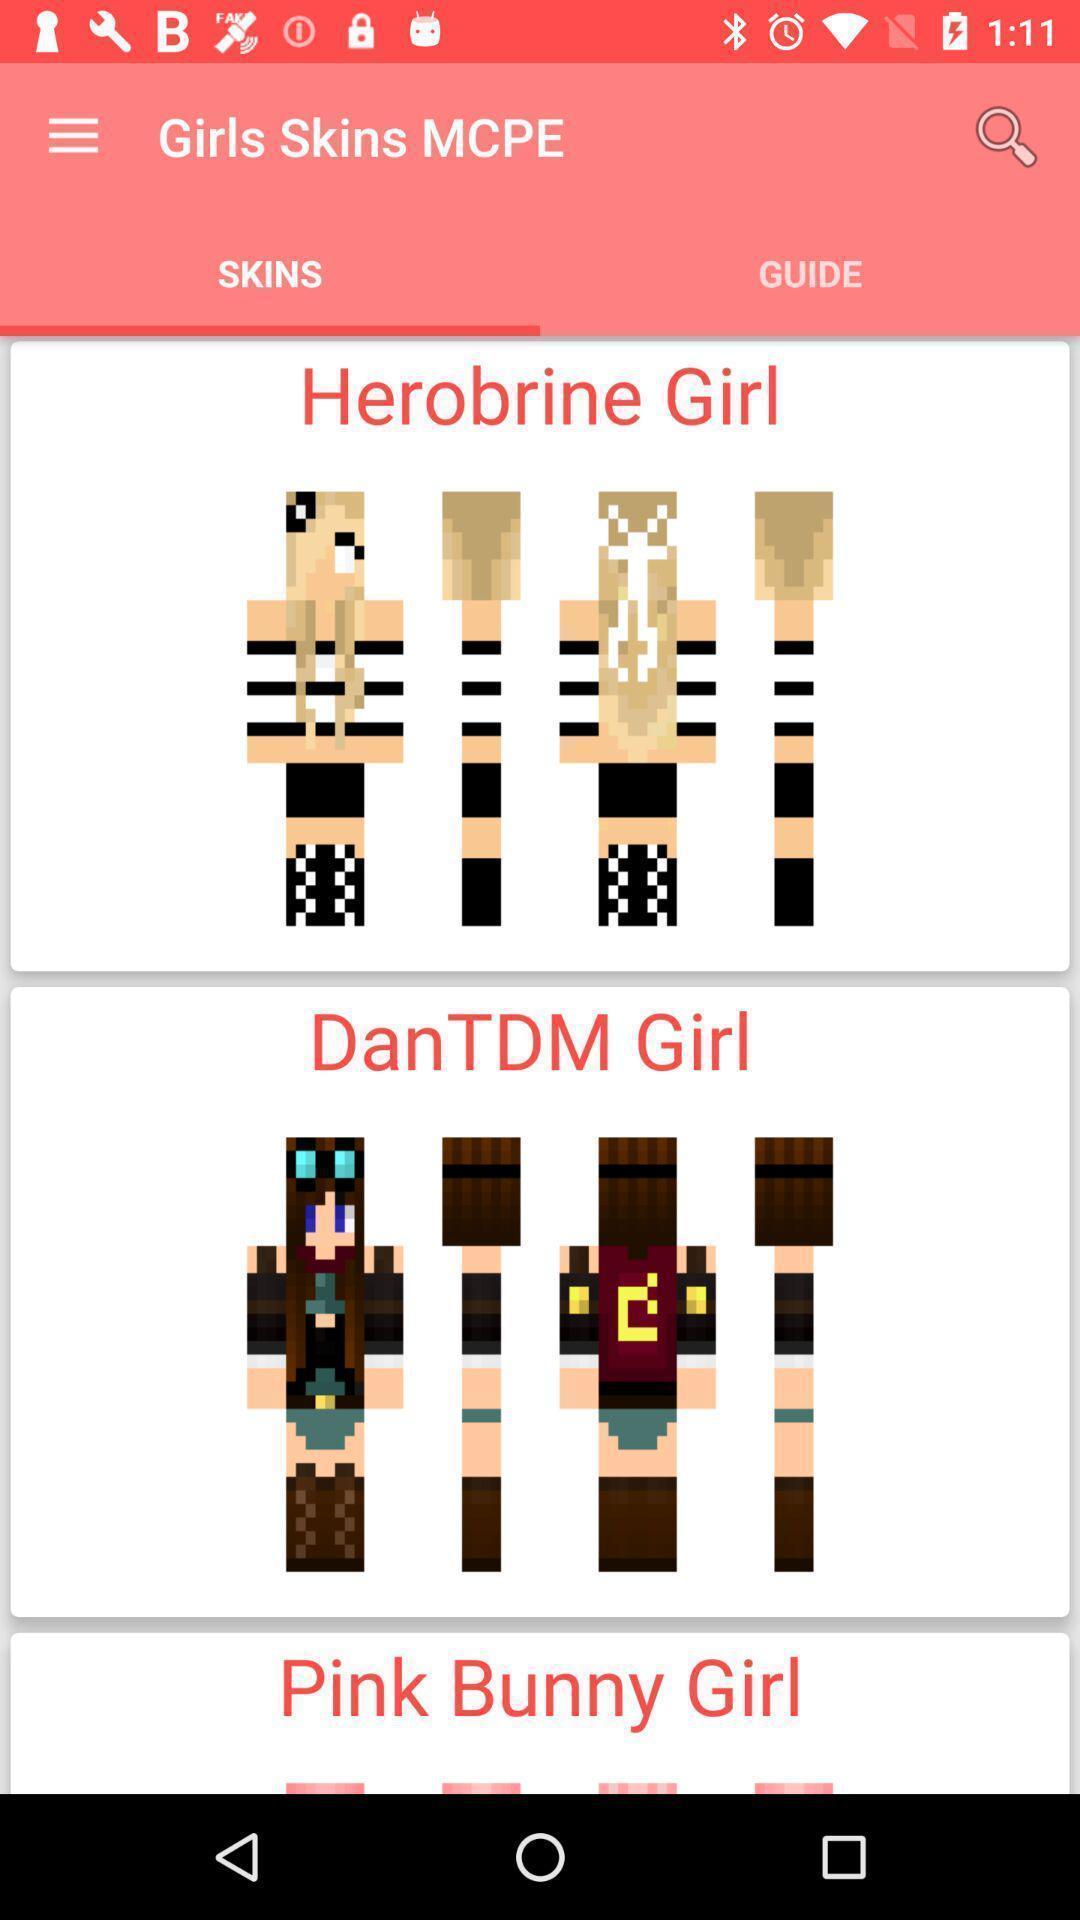Provide a textual representation of this image. Various kinds of girl skins in application with lego persons. 